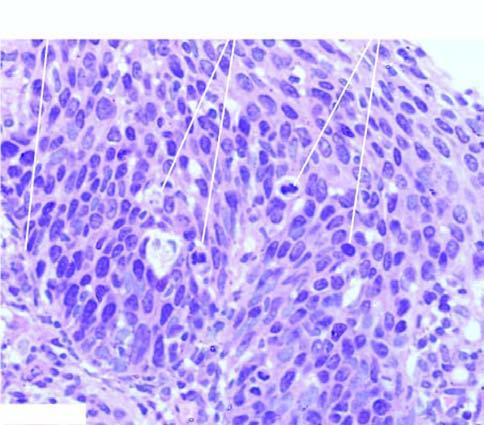s these end components of chromosome intact?
Answer the question using a single word or phrase. No 